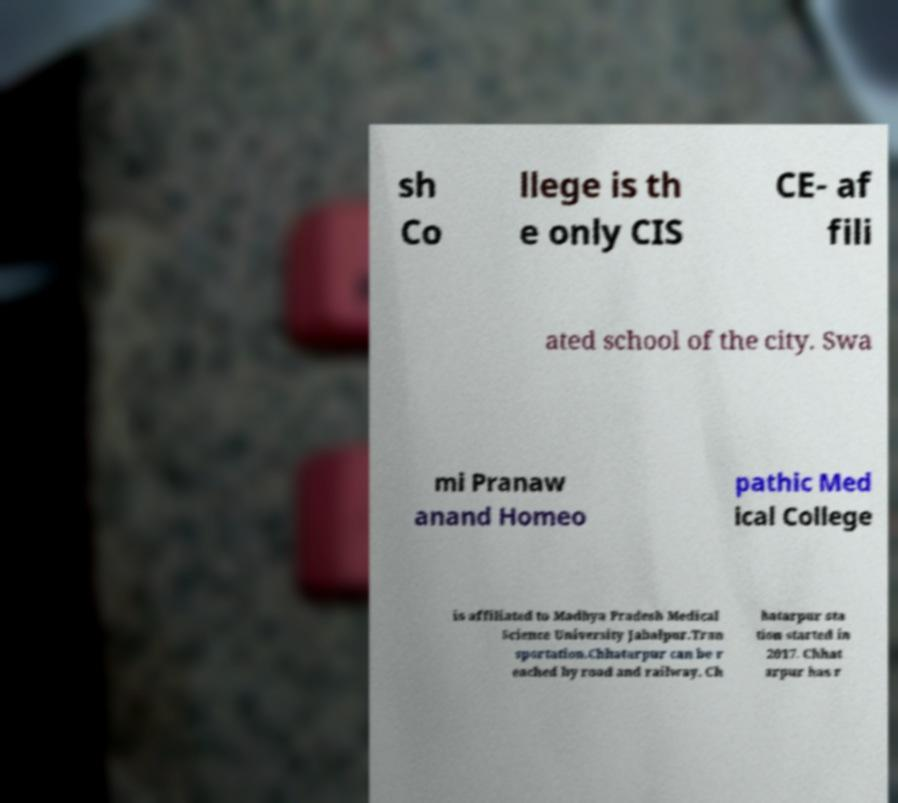For documentation purposes, I need the text within this image transcribed. Could you provide that? sh Co llege is th e only CIS CE- af fili ated school of the city. Swa mi Pranaw anand Homeo pathic Med ical College is affiliated to Madhya Pradesh Medical Science University Jabalpur.Tran sportation.Chhatarpur can be r eached by road and railway. Ch hatarpur sta tion started in 2017. Chhat arpur has r 